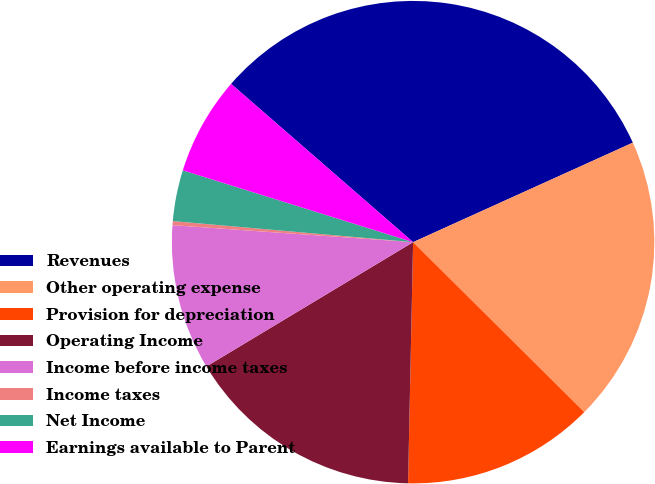Convert chart. <chart><loc_0><loc_0><loc_500><loc_500><pie_chart><fcel>Revenues<fcel>Other operating expense<fcel>Provision for depreciation<fcel>Operating Income<fcel>Income before income taxes<fcel>Income taxes<fcel>Net Income<fcel>Earnings available to Parent<nl><fcel>31.84%<fcel>19.21%<fcel>12.89%<fcel>16.05%<fcel>9.74%<fcel>0.27%<fcel>3.42%<fcel>6.58%<nl></chart> 